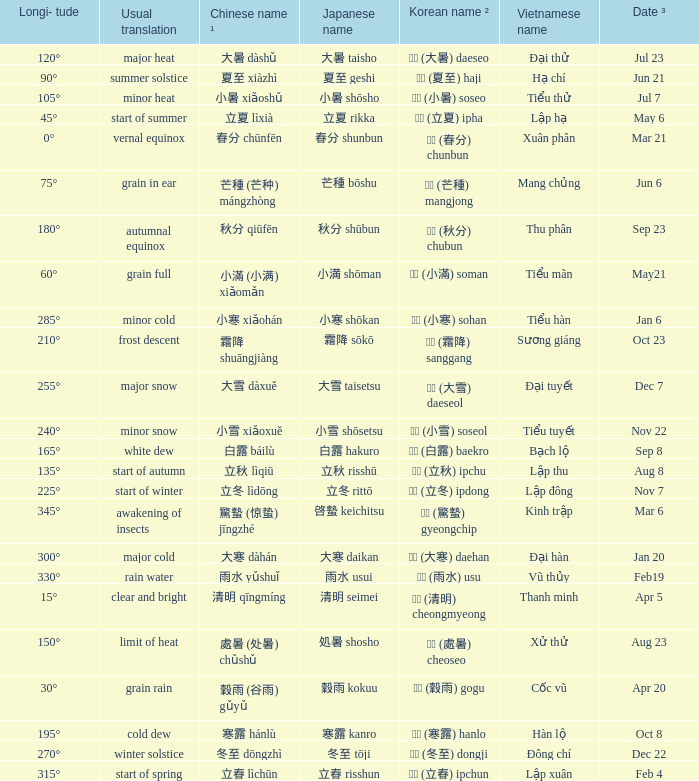WHICH Usual translation is on jun 21? Summer solstice. 